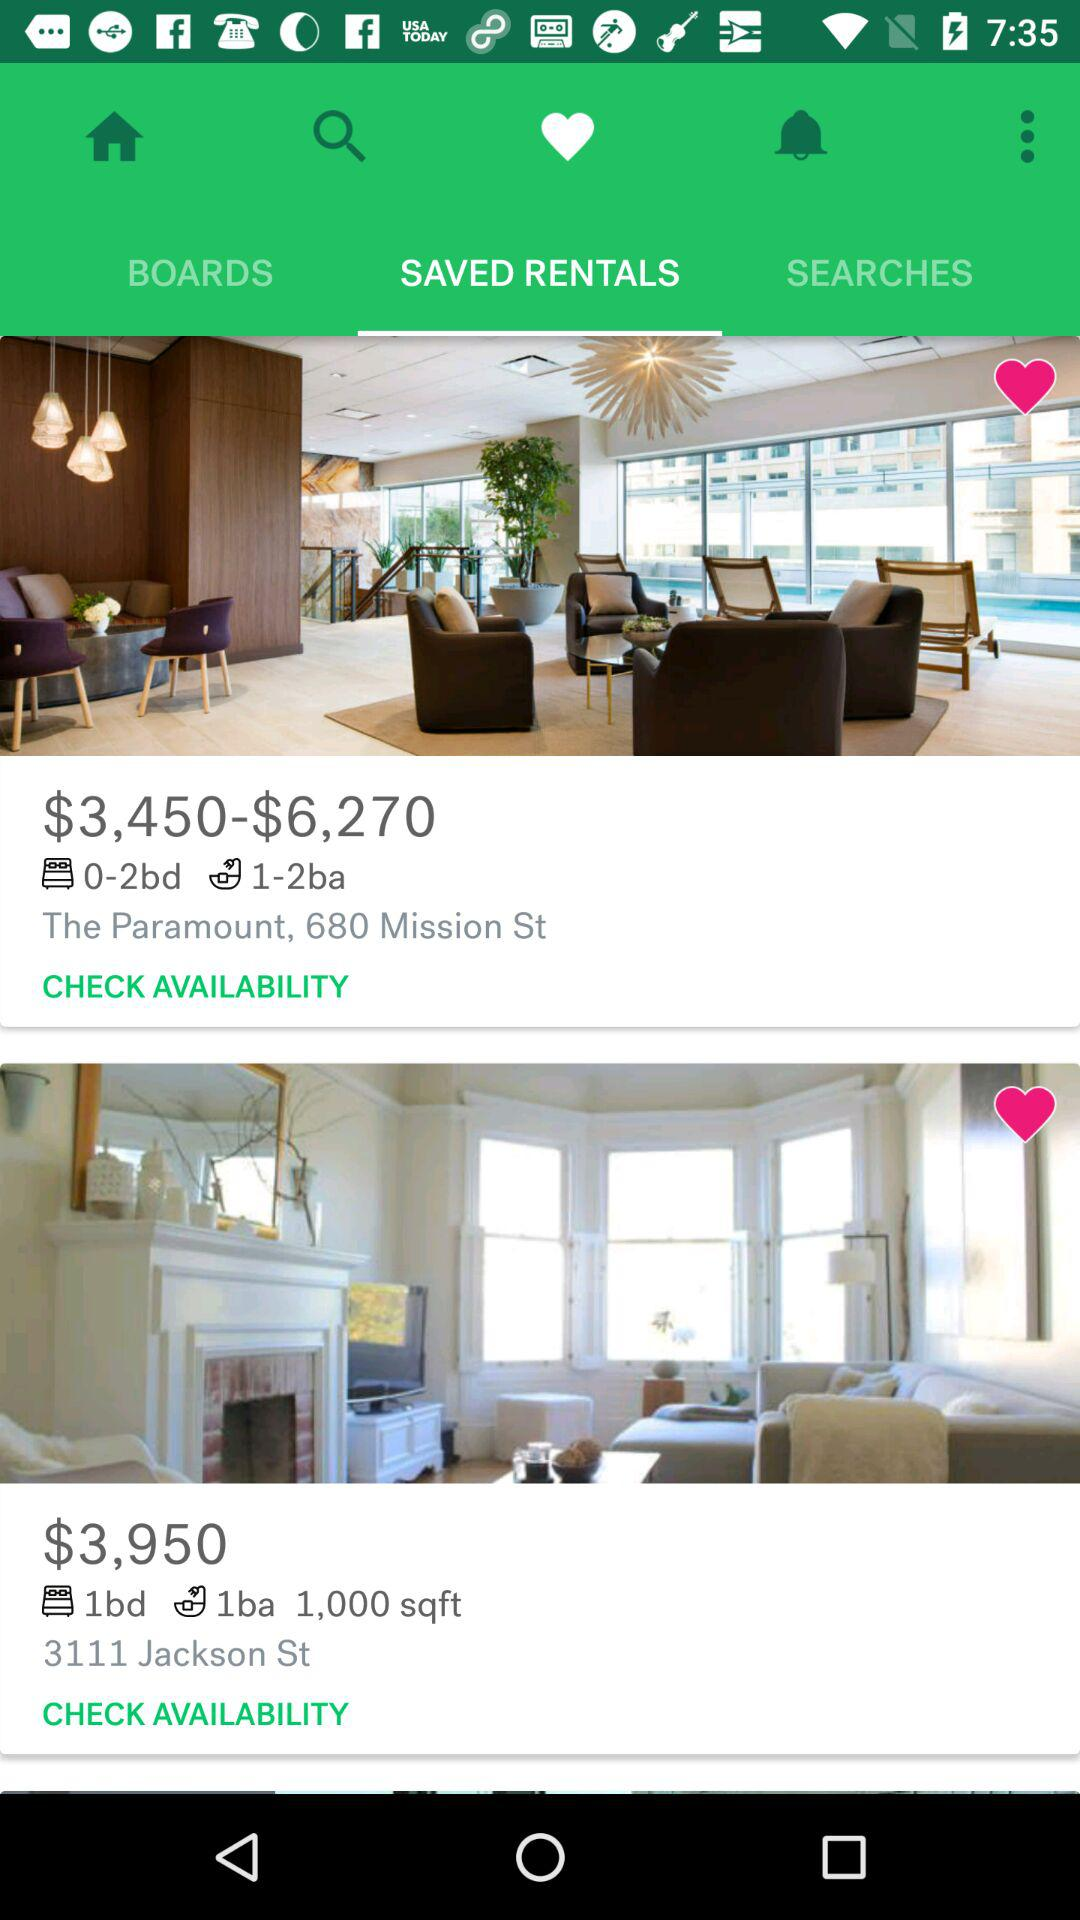What is the square footage of the listing at 680 Mission St?
When the provided information is insufficient, respond with <no answer>. <no answer> 